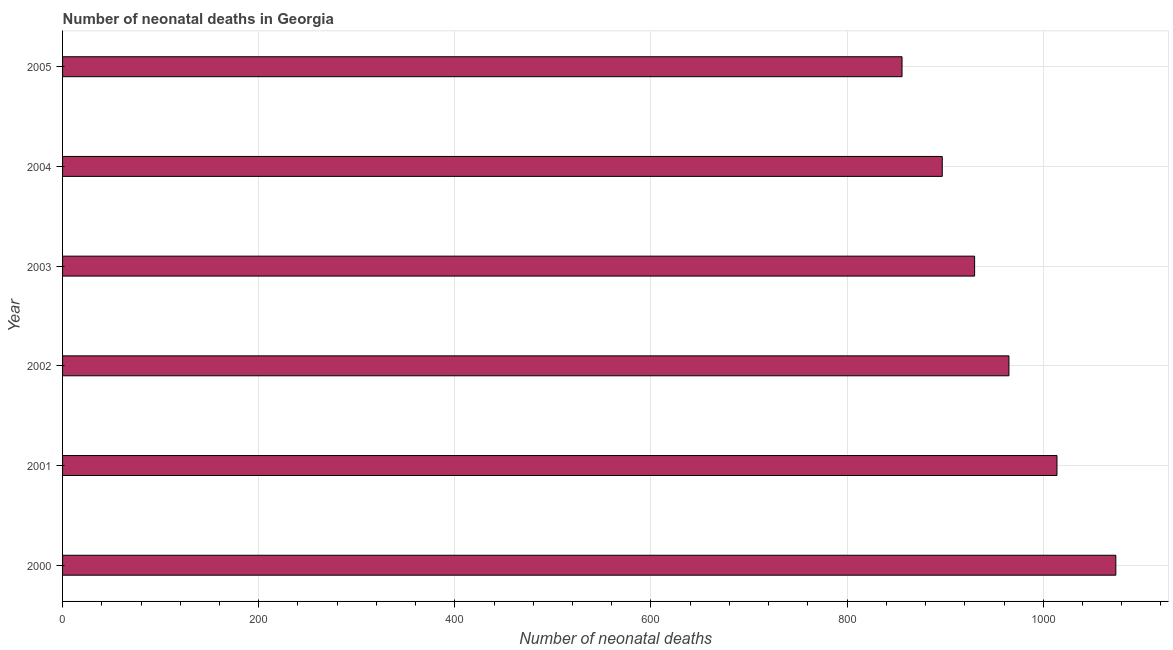Does the graph contain any zero values?
Your response must be concise. No. What is the title of the graph?
Offer a very short reply. Number of neonatal deaths in Georgia. What is the label or title of the X-axis?
Keep it short and to the point. Number of neonatal deaths. What is the label or title of the Y-axis?
Make the answer very short. Year. What is the number of neonatal deaths in 2002?
Keep it short and to the point. 965. Across all years, what is the maximum number of neonatal deaths?
Make the answer very short. 1074. Across all years, what is the minimum number of neonatal deaths?
Your answer should be compact. 856. In which year was the number of neonatal deaths maximum?
Keep it short and to the point. 2000. In which year was the number of neonatal deaths minimum?
Make the answer very short. 2005. What is the sum of the number of neonatal deaths?
Give a very brief answer. 5736. What is the difference between the number of neonatal deaths in 2002 and 2005?
Your response must be concise. 109. What is the average number of neonatal deaths per year?
Offer a terse response. 956. What is the median number of neonatal deaths?
Keep it short and to the point. 947.5. Do a majority of the years between 2002 and 2005 (inclusive) have number of neonatal deaths greater than 160 ?
Offer a very short reply. Yes. What is the ratio of the number of neonatal deaths in 2002 to that in 2003?
Your answer should be very brief. 1.04. What is the difference between the highest and the lowest number of neonatal deaths?
Provide a short and direct response. 218. In how many years, is the number of neonatal deaths greater than the average number of neonatal deaths taken over all years?
Your answer should be very brief. 3. How many bars are there?
Your answer should be very brief. 6. Are all the bars in the graph horizontal?
Offer a terse response. Yes. How many years are there in the graph?
Your answer should be very brief. 6. What is the Number of neonatal deaths in 2000?
Your answer should be compact. 1074. What is the Number of neonatal deaths in 2001?
Give a very brief answer. 1014. What is the Number of neonatal deaths of 2002?
Ensure brevity in your answer.  965. What is the Number of neonatal deaths of 2003?
Offer a terse response. 930. What is the Number of neonatal deaths of 2004?
Your response must be concise. 897. What is the Number of neonatal deaths of 2005?
Keep it short and to the point. 856. What is the difference between the Number of neonatal deaths in 2000 and 2002?
Ensure brevity in your answer.  109. What is the difference between the Number of neonatal deaths in 2000 and 2003?
Your answer should be compact. 144. What is the difference between the Number of neonatal deaths in 2000 and 2004?
Provide a short and direct response. 177. What is the difference between the Number of neonatal deaths in 2000 and 2005?
Offer a very short reply. 218. What is the difference between the Number of neonatal deaths in 2001 and 2002?
Give a very brief answer. 49. What is the difference between the Number of neonatal deaths in 2001 and 2003?
Provide a short and direct response. 84. What is the difference between the Number of neonatal deaths in 2001 and 2004?
Keep it short and to the point. 117. What is the difference between the Number of neonatal deaths in 2001 and 2005?
Your answer should be very brief. 158. What is the difference between the Number of neonatal deaths in 2002 and 2004?
Offer a very short reply. 68. What is the difference between the Number of neonatal deaths in 2002 and 2005?
Offer a very short reply. 109. What is the difference between the Number of neonatal deaths in 2003 and 2005?
Your answer should be very brief. 74. What is the ratio of the Number of neonatal deaths in 2000 to that in 2001?
Provide a succinct answer. 1.06. What is the ratio of the Number of neonatal deaths in 2000 to that in 2002?
Ensure brevity in your answer.  1.11. What is the ratio of the Number of neonatal deaths in 2000 to that in 2003?
Provide a succinct answer. 1.16. What is the ratio of the Number of neonatal deaths in 2000 to that in 2004?
Give a very brief answer. 1.2. What is the ratio of the Number of neonatal deaths in 2000 to that in 2005?
Offer a terse response. 1.25. What is the ratio of the Number of neonatal deaths in 2001 to that in 2002?
Offer a very short reply. 1.05. What is the ratio of the Number of neonatal deaths in 2001 to that in 2003?
Give a very brief answer. 1.09. What is the ratio of the Number of neonatal deaths in 2001 to that in 2004?
Make the answer very short. 1.13. What is the ratio of the Number of neonatal deaths in 2001 to that in 2005?
Give a very brief answer. 1.19. What is the ratio of the Number of neonatal deaths in 2002 to that in 2003?
Your answer should be compact. 1.04. What is the ratio of the Number of neonatal deaths in 2002 to that in 2004?
Your answer should be compact. 1.08. What is the ratio of the Number of neonatal deaths in 2002 to that in 2005?
Keep it short and to the point. 1.13. What is the ratio of the Number of neonatal deaths in 2003 to that in 2004?
Offer a terse response. 1.04. What is the ratio of the Number of neonatal deaths in 2003 to that in 2005?
Offer a very short reply. 1.09. What is the ratio of the Number of neonatal deaths in 2004 to that in 2005?
Give a very brief answer. 1.05. 